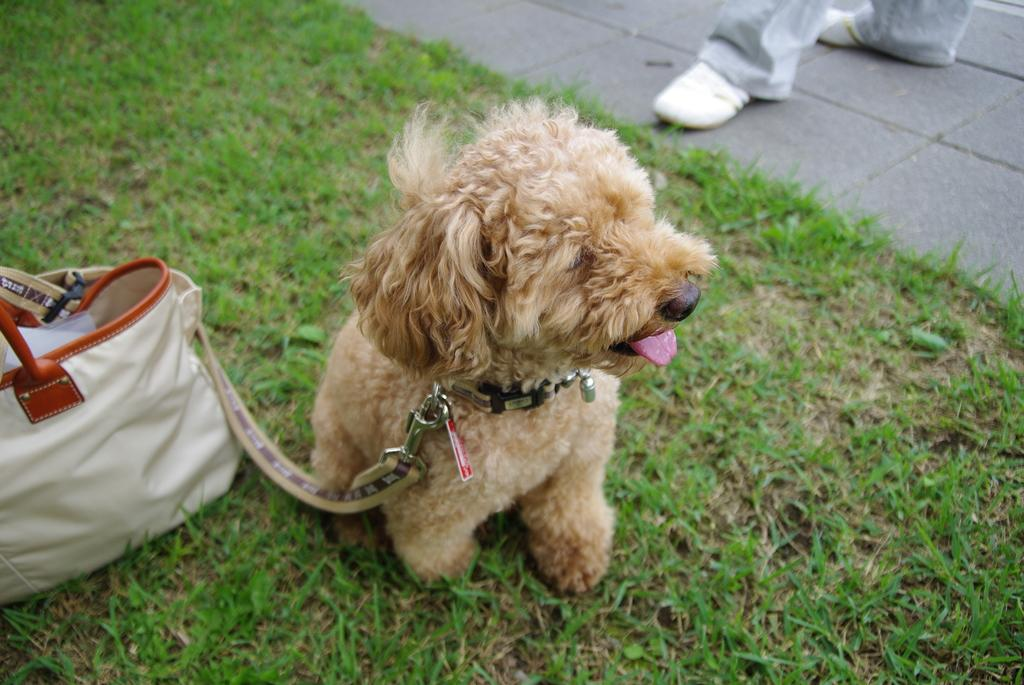What object is on the ground in the image? There is a handbag on the ground in the image. What type of animal is present in the image? There is a dog in the image. How is the dog adorned in the image? The dog has a belt around its neck. What part of a person can be seen in the image? Human legs are visible in the image. What type of surface is the handbag and dog on? There is grass on the ground in the image. What is the color of the dog in the image? The dog is light brown in color. How does the dog balance a bike on its nose in the image? There is no bike present in the image, and the dog is not balancing anything on its nose. Does the dog have a crown on its head in the image? No, the dog does not have a crown on its head in the image. 